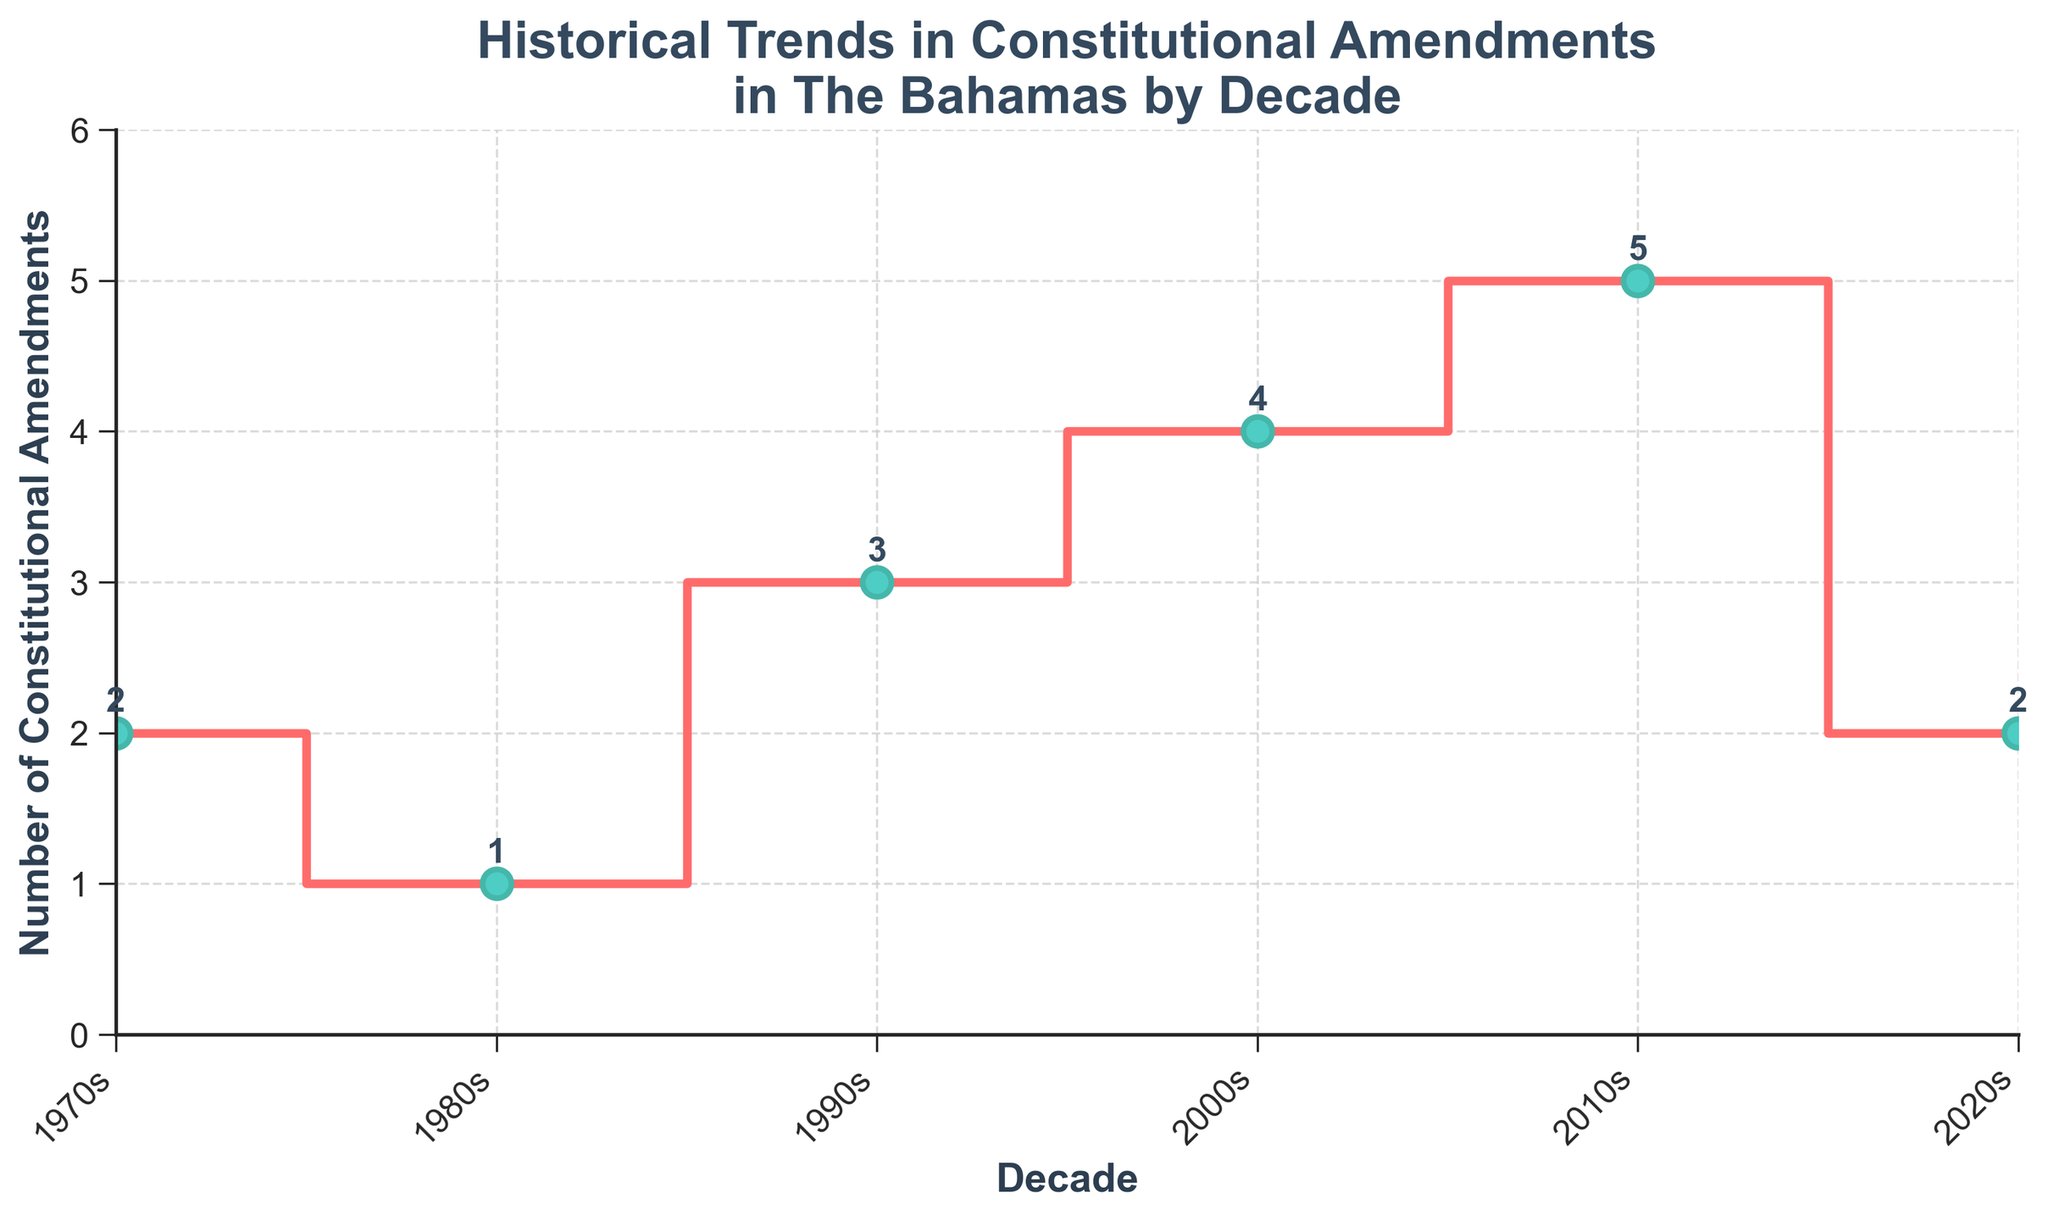what is the title of the figure? The figure has a title at the top, which reads "Historical Trends in Constitutional Amendments in The Bahamas by Decade".
Answer: Historical Trends in Constitutional Amendments in The Bahamas by Decade what is the highest number of constitutional amendments in a decade? By looking at the y-axis and the annotations above the points, the highest number of amendments is recorded in the 2010s decade with a count of 5.
Answer: 5 which decade saw the lowest number of constitutional amendments? By checking the amendment count for each decade, the 1980s had the lowest number with only 1 amendment.
Answer: 1980s what is the average number of constitutional amendments across all decades? The counts for the decades are 2, 1, 3, 4, 5, and 2. Their sum is 17, and there are 6 decades. The average is therefore 17/6 ≈ 2.83.
Answer: 2.83 how many decades had more than 2 constitutional amendments? By inspecting the counts, the 1990s, 2000s, and 2010s had more than 2 amendments. This gives us three decades.
Answer: 3 which two decades have the same number of constitutional amendments? The years 1970s (2 amendments) and 2020s (2 amendments) both show the same count.
Answer: 1970s and 2020s how does the number of amendments in the 2010s compare to the 1980s? The 2010s had 5 amendments, while the 1980s had 1 amendment. Therefore, the 2010s had 4 more amendments than the 1980s.
Answer: 4 more what trend do you observe in the number of amendments from the 1990s to the 2010s? The number of amendments increased during this period, rising from 3 in the 1990s to 4 in the 2000s, and then to 5 in the 2010s.
Answer: increasing trend what is the difference in the number of amendments between the most active and least active decades? The 2010s had the highest count with 5 amendments, and the 1980s had the lowest with 1 amendment. The difference is 5 - 1 = 4.
Answer: 4 